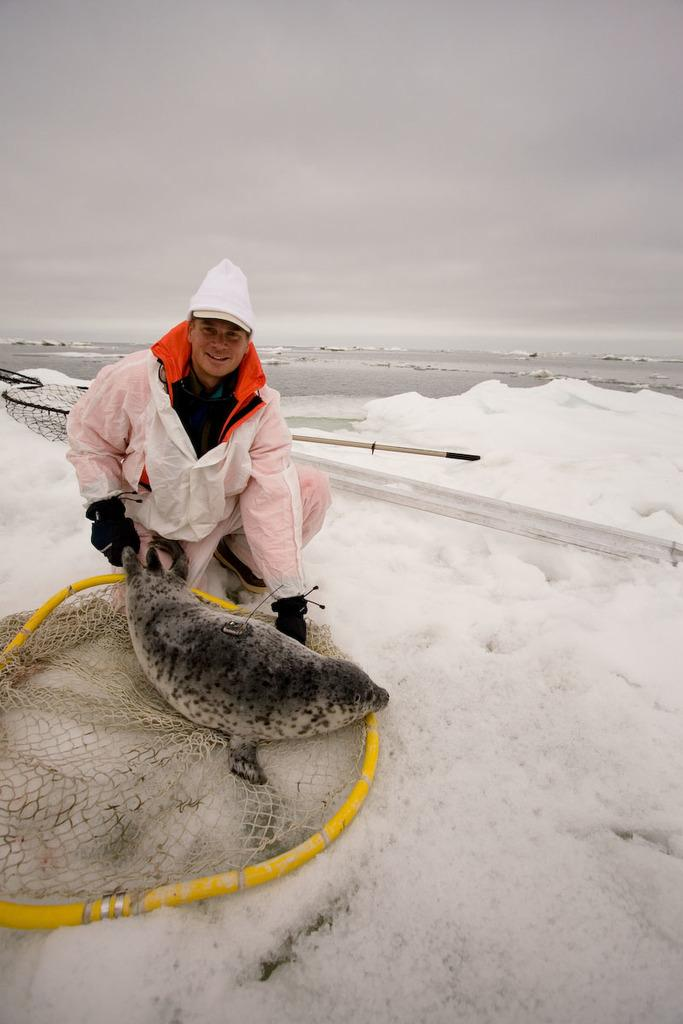Who is present in the image? There is a man in the image. What is the man holding in his hand? The man is holding a seal in his hand. What is the man's facial expression? The man is smiling. What is the condition of the ground in the image? There is snow on the ground in the image. What is present on the snow? There is a net on the snow. How would you describe the sky in the image? The sky is cloudy. What is the distance between the man and his dad in the image? There is no mention of a dad or any other person in the image, so it is not possible to determine the distance between the man and his dad. 